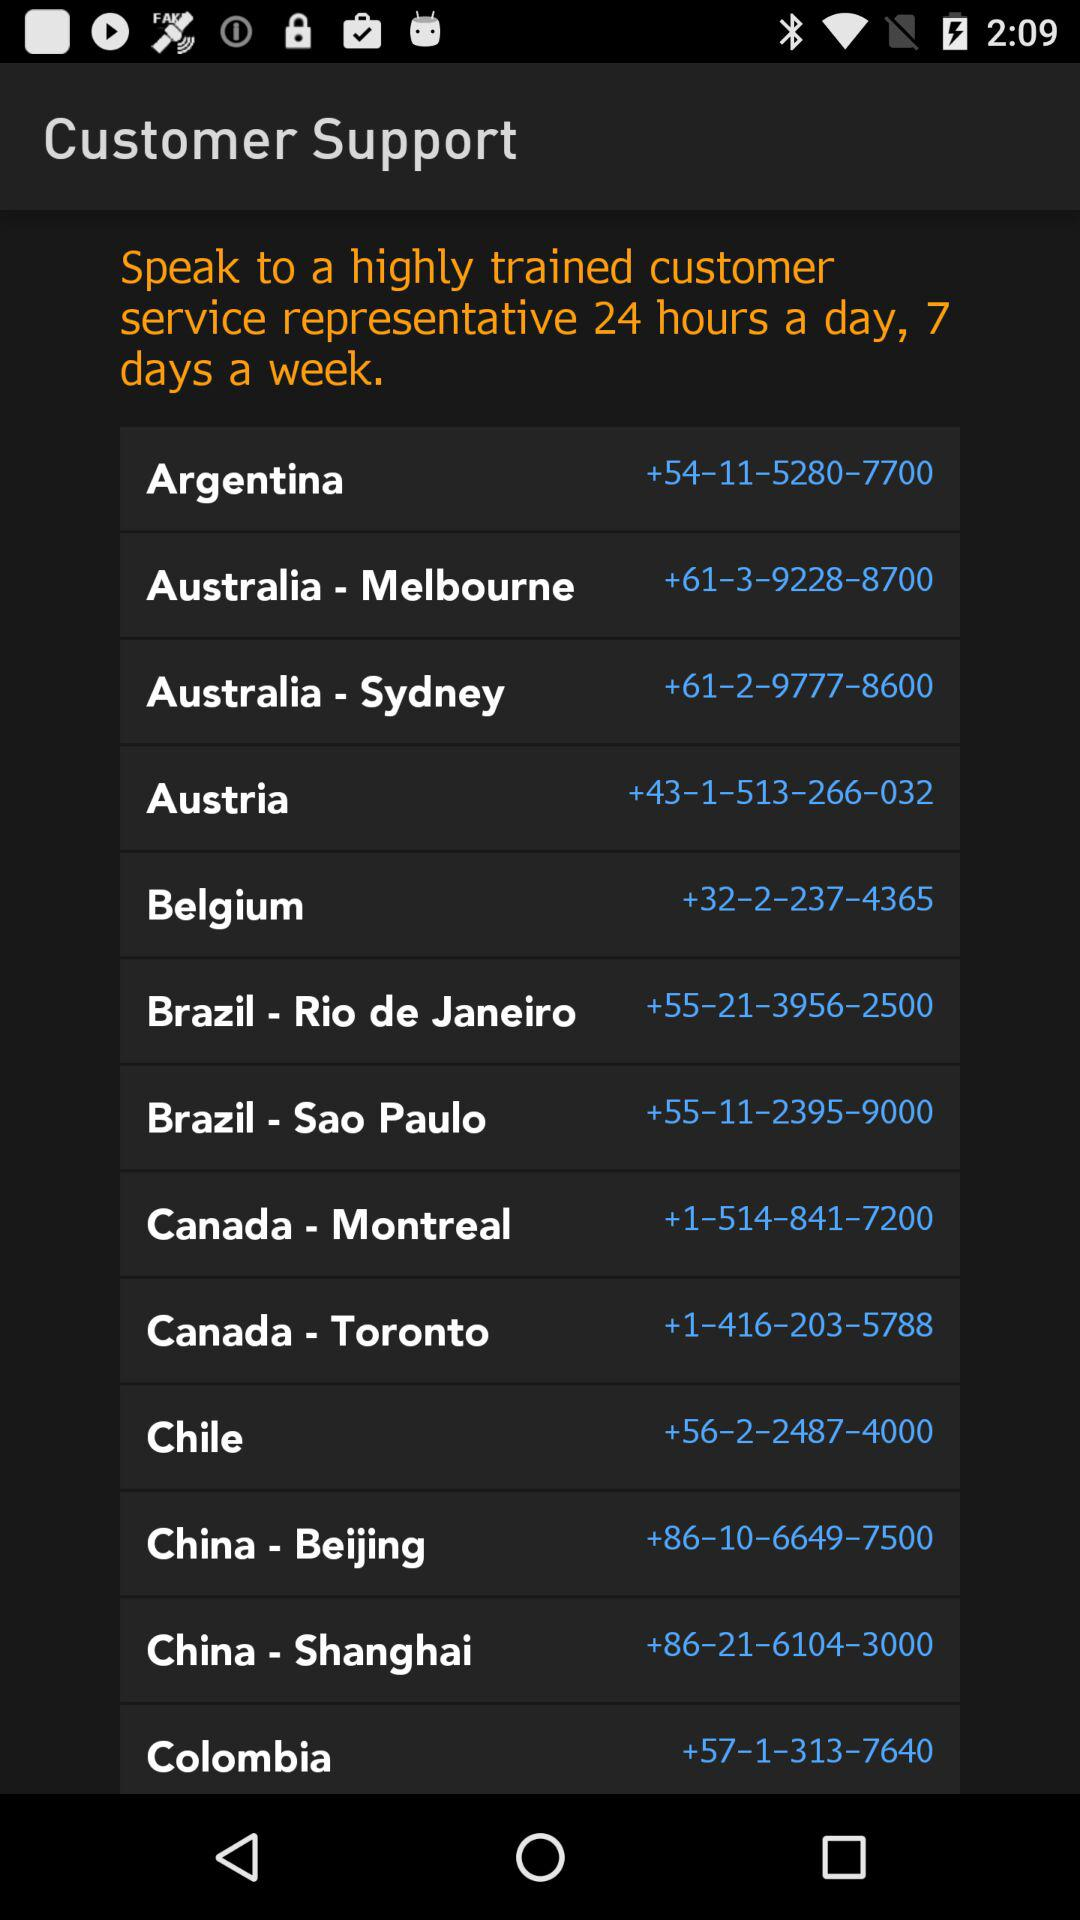+57-1-313-7640 is the contact number of which country? +57-1-313-7640 is the contact number for Colombia. 